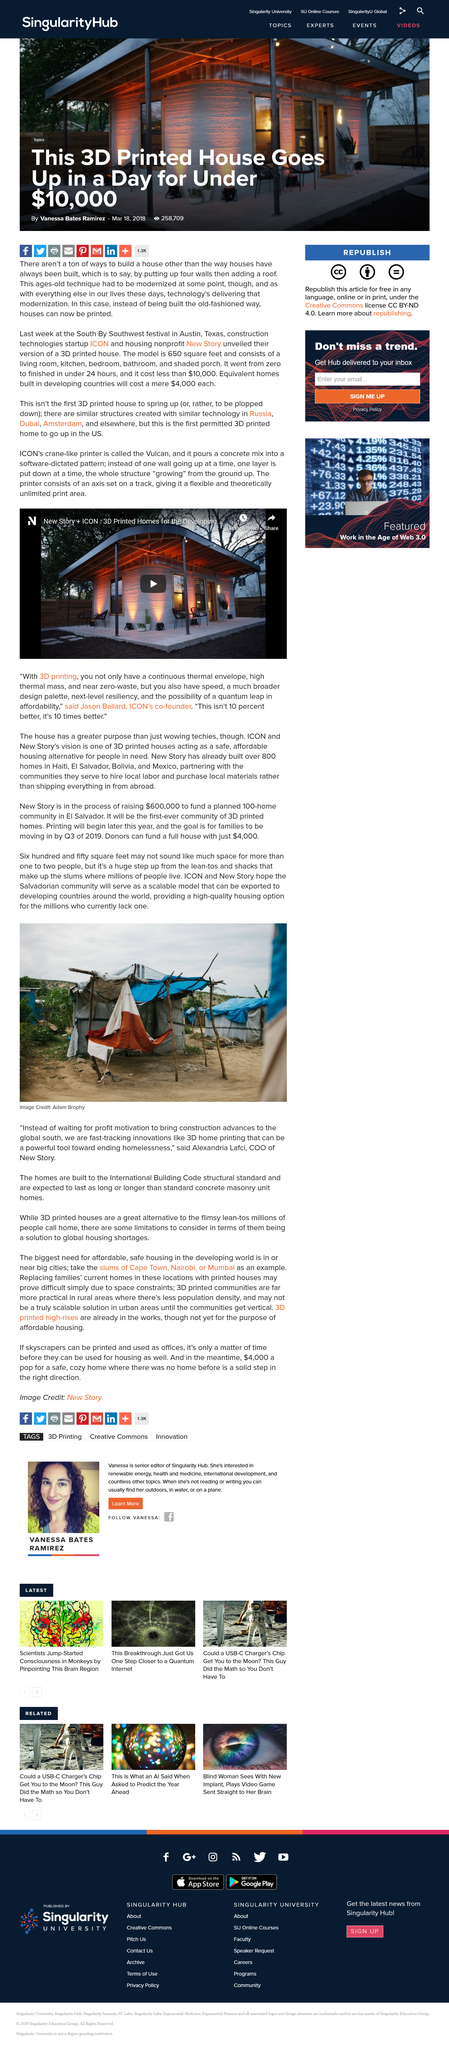Identify some key points in this picture. The 3D printed homes are built to meet the structural standards outlined in the International Building Code, ensuring that they are safe and durable for their occupants. We aim to create a Salvadorian community that serves as a scalable model and can be exported to developing countries as a successful and replicable example. Alexandria Lafci is the Chief Operating Officer of New Story. 